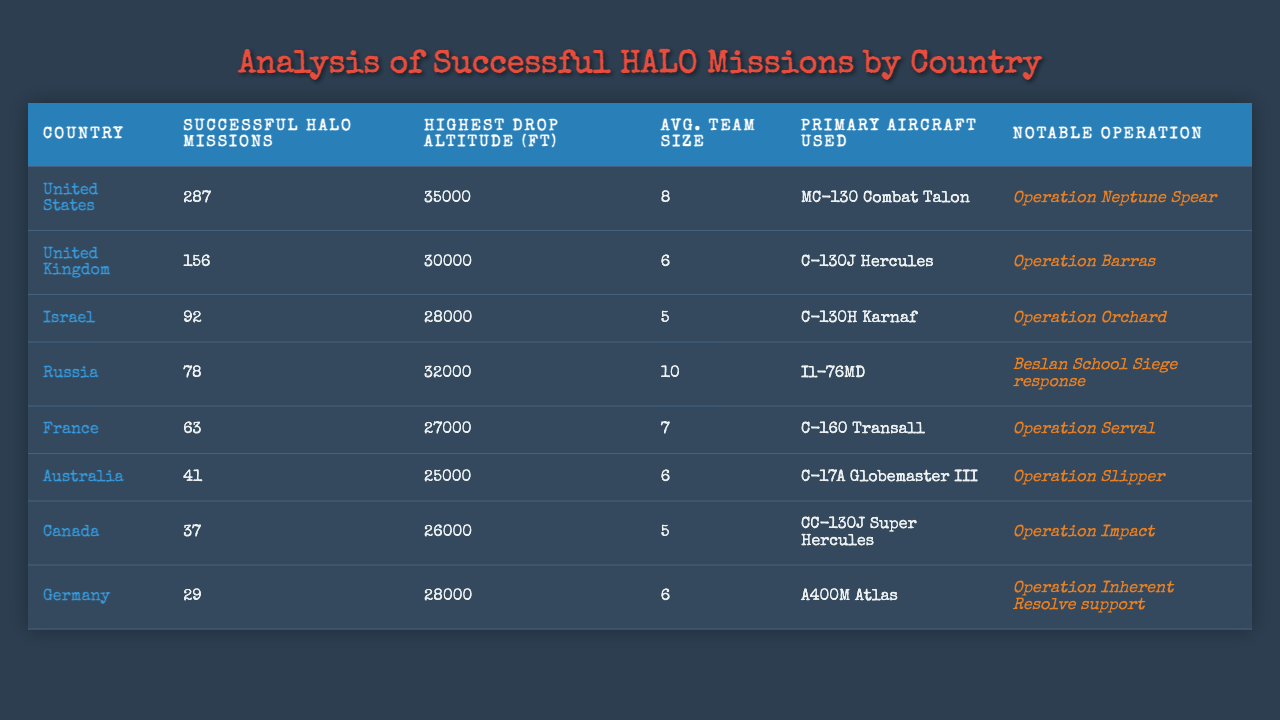What country has the highest number of successful HALO missions? The table shows the number of successful HALO missions by country. The United States has 287 successful missions, which is higher than any other country listed.
Answer: United States What was the highest drop altitude recorded in the missions? Looking at the "Highest Drop Altitude (ft)" column, the highest recorded drop altitude is 35,000 feet, which corresponds to the United States.
Answer: 35000 ft What is the average team size for HALO missions by Israel? From the table, Israel has an average team size of 5 for their successful HALO missions. This is directly available in the "Avg. Team Size" column.
Answer: 5 Which country used the MC-130 Combat Talon aircraft for their HALO operations? The table indicates that the primary aircraft used by the United States for HALO operations is the MC-130 Combat Talon.
Answer: United States How many more successful HALO missions did the United States have compared to France? The United States had 287 successful missions, while France had 63. The difference is calculated as 287 - 63 = 224.
Answer: 224 Is it true that Canada has a higher average team size than Germany for HALO missions? Canada has an average team size of 5, whereas Germany has an average team size of 6. Since 5 is less than 6, the statement is false.
Answer: No Which country had a notable operation called "Operation Barras"? According to the "Notable Operation" column, the United Kingdom is associated with the notable operation "Operation Barras."
Answer: United Kingdom What is the total number of successful HALO missions recorded for all countries listed? By adding the successful HALO missions from each country (287 + 156 + 92 + 78 + 63 + 41 + 37 + 29), the total comes to 783.
Answer: 783 Which country has the lowest number of successful HALO missions? Looking at the data, Germany has the lowest number of successful HALO missions, with only 29 missions listed.
Answer: Germany What country had the operation named "Operation Orchard"? According to the table, Israel conducted the notable operation named "Operation Orchard."
Answer: Israel 